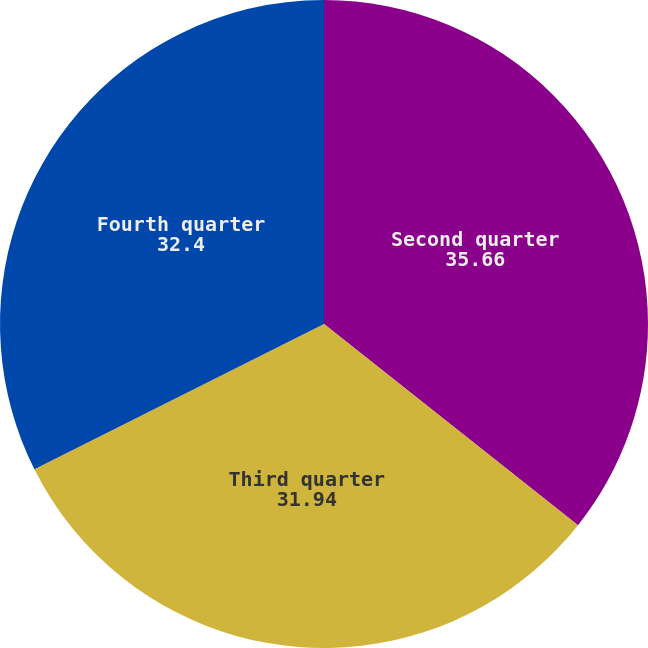Convert chart. <chart><loc_0><loc_0><loc_500><loc_500><pie_chart><fcel>Second quarter<fcel>Third quarter<fcel>Fourth quarter<nl><fcel>35.66%<fcel>31.94%<fcel>32.4%<nl></chart> 